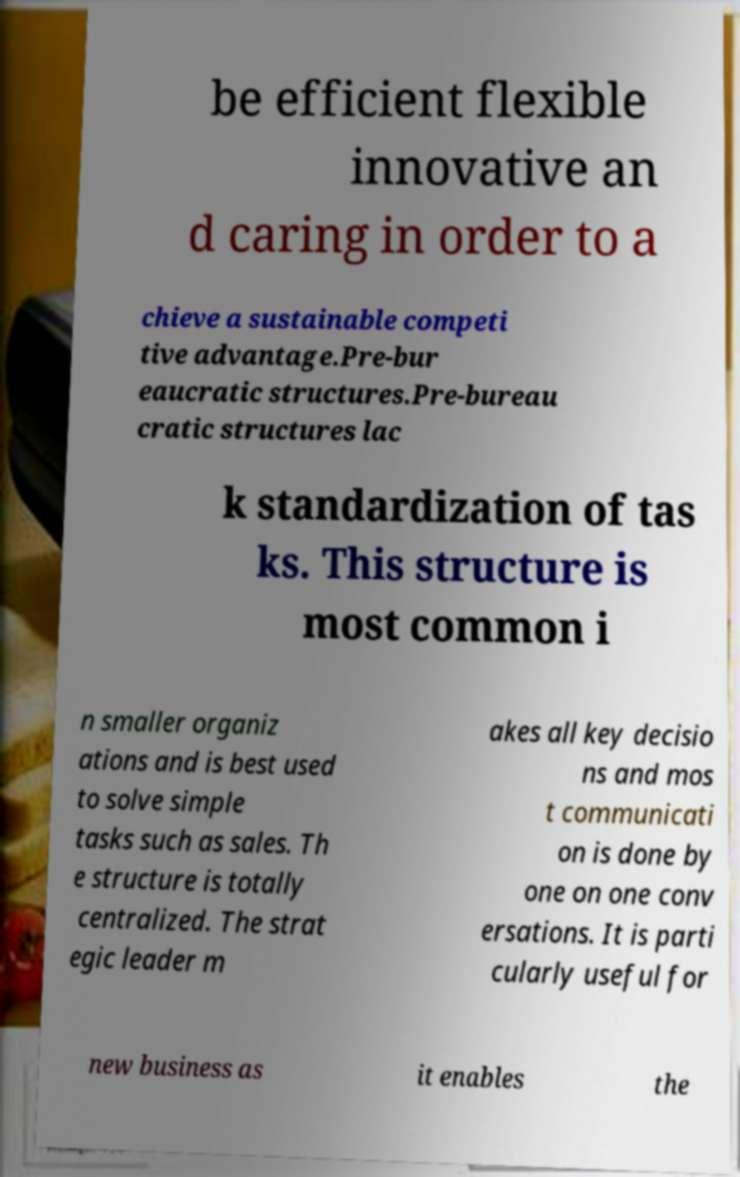There's text embedded in this image that I need extracted. Can you transcribe it verbatim? be efficient flexible innovative an d caring in order to a chieve a sustainable competi tive advantage.Pre-bur eaucratic structures.Pre-bureau cratic structures lac k standardization of tas ks. This structure is most common i n smaller organiz ations and is best used to solve simple tasks such as sales. Th e structure is totally centralized. The strat egic leader m akes all key decisio ns and mos t communicati on is done by one on one conv ersations. It is parti cularly useful for new business as it enables the 